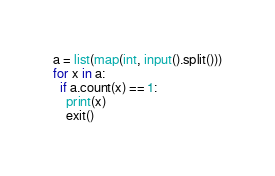Convert code to text. <code><loc_0><loc_0><loc_500><loc_500><_Python_>a = list(map(int, input().split()))
for x in a:
  if a.count(x) == 1:
    print(x)
    exit()
</code> 